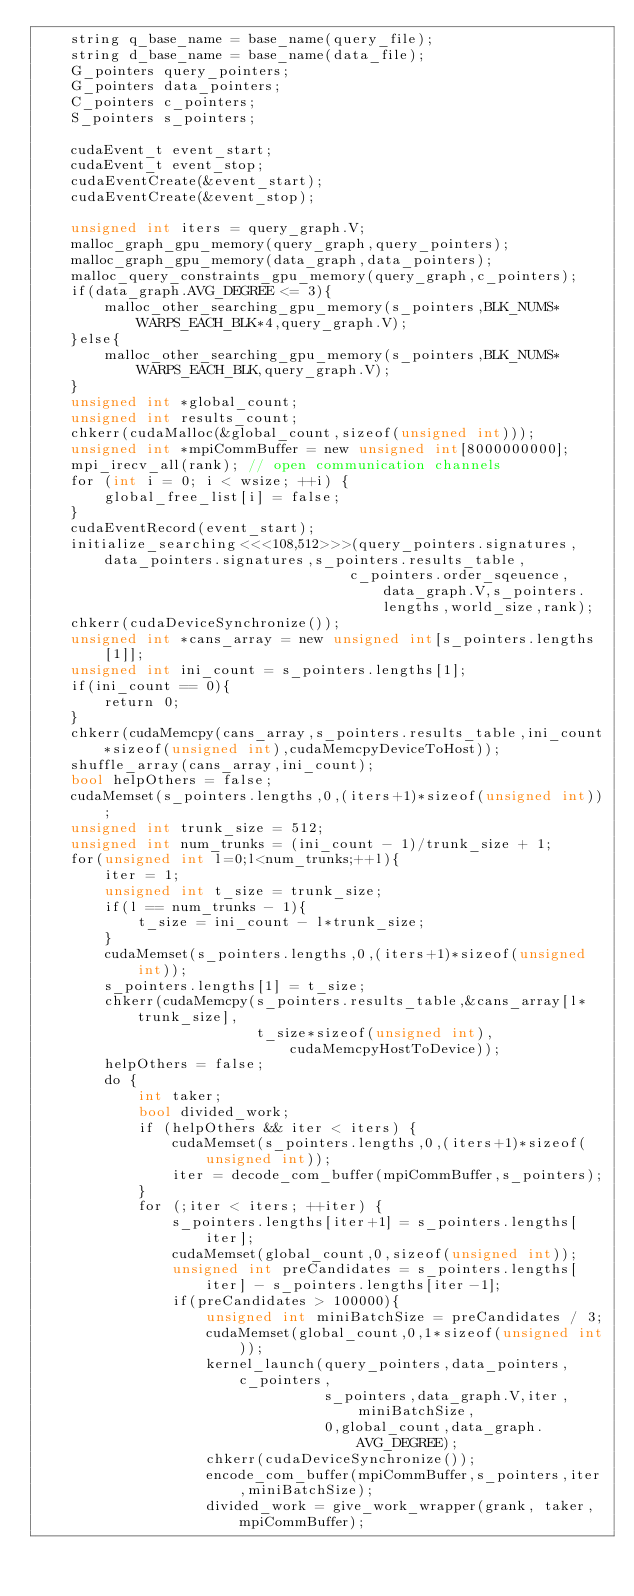<code> <loc_0><loc_0><loc_500><loc_500><_Cuda_>    string q_base_name = base_name(query_file);
    string d_base_name = base_name(data_file);
    G_pointers query_pointers;
    G_pointers data_pointers;
    C_pointers c_pointers;
    S_pointers s_pointers;

    cudaEvent_t event_start;
    cudaEvent_t event_stop;
    cudaEventCreate(&event_start);
    cudaEventCreate(&event_stop);

    unsigned int iters = query_graph.V;
    malloc_graph_gpu_memory(query_graph,query_pointers);
    malloc_graph_gpu_memory(data_graph,data_pointers);
    malloc_query_constraints_gpu_memory(query_graph,c_pointers);
    if(data_graph.AVG_DEGREE <= 3){
        malloc_other_searching_gpu_memory(s_pointers,BLK_NUMS*WARPS_EACH_BLK*4,query_graph.V);
    }else{
        malloc_other_searching_gpu_memory(s_pointers,BLK_NUMS*WARPS_EACH_BLK,query_graph.V);
    }
    unsigned int *global_count;
    unsigned int results_count;
    chkerr(cudaMalloc(&global_count,sizeof(unsigned int)));
    unsigned int *mpiCommBuffer = new unsigned int[8000000000];
    mpi_irecv_all(rank); // open communication channels
    for (int i = 0; i < wsize; ++i) {
        global_free_list[i] = false;
    }
    cudaEventRecord(event_start);
    initialize_searching<<<108,512>>>(query_pointers.signatures,data_pointers.signatures,s_pointers.results_table,
                                     c_pointers.order_sqeuence,data_graph.V,s_pointers.lengths,world_size,rank);
    chkerr(cudaDeviceSynchronize());
    unsigned int *cans_array = new unsigned int[s_pointers.lengths[1]];
    unsigned int ini_count = s_pointers.lengths[1];
    if(ini_count == 0){
        return 0;
    }
    chkerr(cudaMemcpy(cans_array,s_pointers.results_table,ini_count*sizeof(unsigned int),cudaMemcpyDeviceToHost));
    shuffle_array(cans_array,ini_count);
    bool helpOthers = false;
    cudaMemset(s_pointers.lengths,0,(iters+1)*sizeof(unsigned int));
    unsigned int trunk_size = 512;
    unsigned int num_trunks = (ini_count - 1)/trunk_size + 1;
    for(unsigned int l=0;l<num_trunks;++l){
        iter = 1;
        unsigned int t_size = trunk_size;
        if(l == num_trunks - 1){
            t_size = ini_count - l*trunk_size;
        }
        cudaMemset(s_pointers.lengths,0,(iters+1)*sizeof(unsigned int));
        s_pointers.lengths[1] = t_size;
        chkerr(cudaMemcpy(s_pointers.results_table,&cans_array[l*trunk_size],
                          t_size*sizeof(unsigned int),cudaMemcpyHostToDevice));
        helpOthers = false;
        do {
            int taker;
            bool divided_work;
            if (helpOthers && iter < iters) {
                cudaMemset(s_pointers.lengths,0,(iters+1)*sizeof(unsigned int));
                iter = decode_com_buffer(mpiCommBuffer,s_pointers);
            }
            for (;iter < iters; ++iter) {
                s_pointers.lengths[iter+1] = s_pointers.lengths[iter];
                cudaMemset(global_count,0,sizeof(unsigned int));
                unsigned int preCandidates = s_pointers.lengths[iter] - s_pointers.lengths[iter-1];
                if(preCandidates > 100000){
                    unsigned int miniBatchSize = preCandidates / 3;
                    cudaMemset(global_count,0,1*sizeof(unsigned int));
                    kernel_launch(query_pointers,data_pointers,c_pointers,
                                  s_pointers,data_graph.V,iter,miniBatchSize,
                                  0,global_count,data_graph.AVG_DEGREE);
                    chkerr(cudaDeviceSynchronize());
                    encode_com_buffer(mpiCommBuffer,s_pointers,iter,miniBatchSize);
                    divided_work = give_work_wrapper(grank, taker, mpiCommBuffer);</code> 